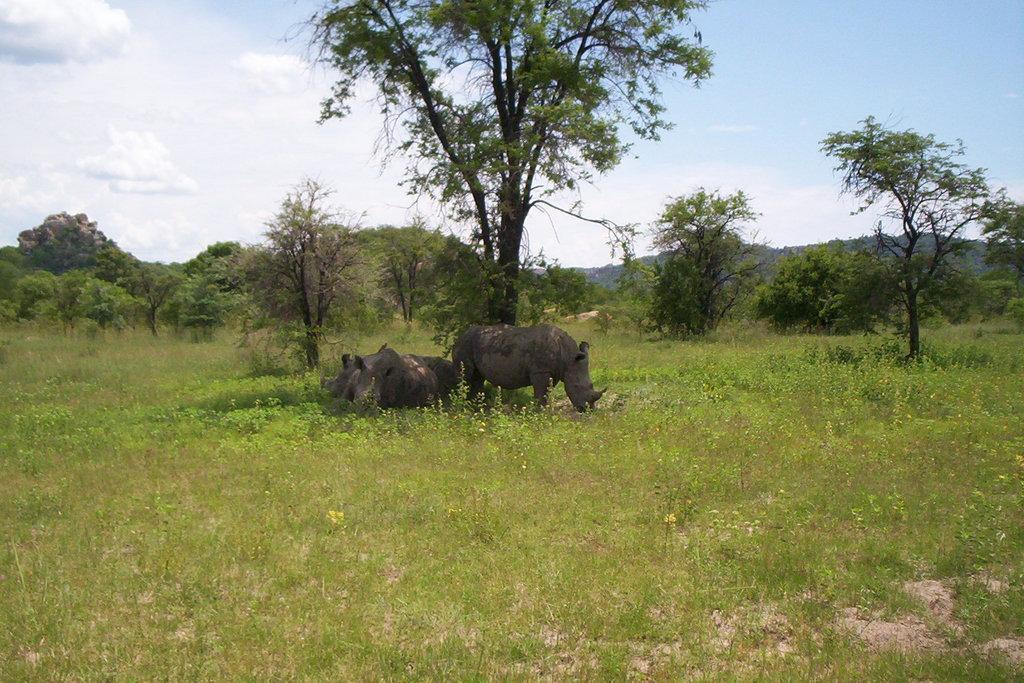In one or two sentences, can you explain what this image depicts? In this image there are animals, trees, grass, plants, hills and cloudy sky. Land is covered with grass. 